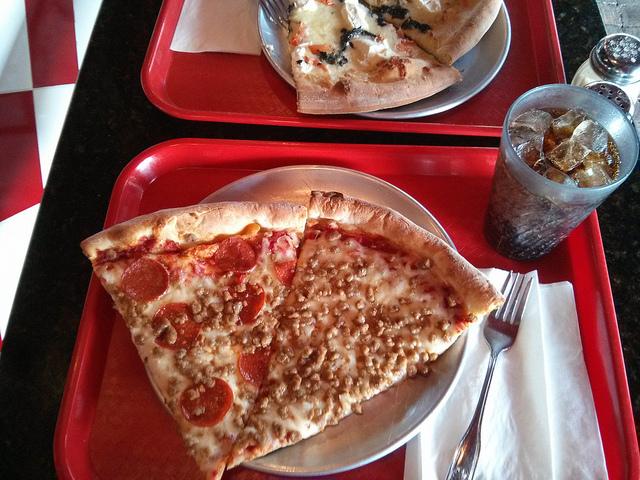Is this breakfast?
Be succinct. No. Is the liquid in the glass water?
Concise answer only. No. Is the fork necessary?
Concise answer only. No. 